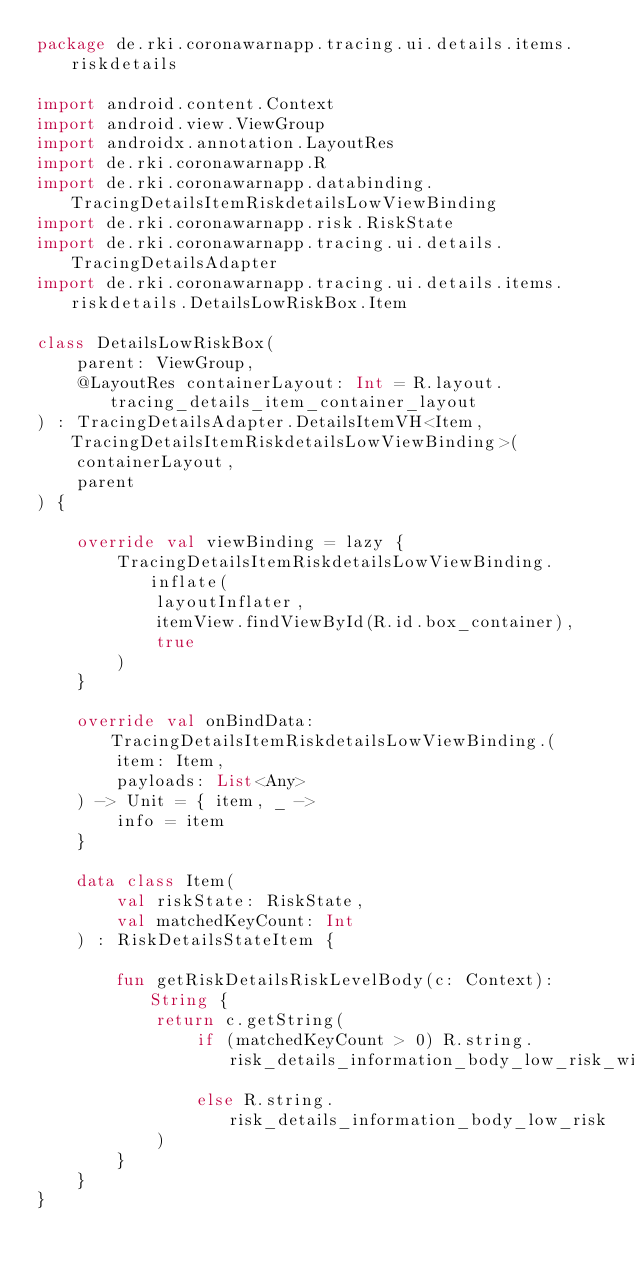<code> <loc_0><loc_0><loc_500><loc_500><_Kotlin_>package de.rki.coronawarnapp.tracing.ui.details.items.riskdetails

import android.content.Context
import android.view.ViewGroup
import androidx.annotation.LayoutRes
import de.rki.coronawarnapp.R
import de.rki.coronawarnapp.databinding.TracingDetailsItemRiskdetailsLowViewBinding
import de.rki.coronawarnapp.risk.RiskState
import de.rki.coronawarnapp.tracing.ui.details.TracingDetailsAdapter
import de.rki.coronawarnapp.tracing.ui.details.items.riskdetails.DetailsLowRiskBox.Item

class DetailsLowRiskBox(
    parent: ViewGroup,
    @LayoutRes containerLayout: Int = R.layout.tracing_details_item_container_layout
) : TracingDetailsAdapter.DetailsItemVH<Item, TracingDetailsItemRiskdetailsLowViewBinding>(
    containerLayout,
    parent
) {

    override val viewBinding = lazy {
        TracingDetailsItemRiskdetailsLowViewBinding.inflate(
            layoutInflater,
            itemView.findViewById(R.id.box_container),
            true
        )
    }

    override val onBindData: TracingDetailsItemRiskdetailsLowViewBinding.(
        item: Item,
        payloads: List<Any>
    ) -> Unit = { item, _ ->
        info = item
    }

    data class Item(
        val riskState: RiskState,
        val matchedKeyCount: Int
    ) : RiskDetailsStateItem {

        fun getRiskDetailsRiskLevelBody(c: Context): String {
            return c.getString(
                if (matchedKeyCount > 0) R.string.risk_details_information_body_low_risk_with_encounter
                else R.string.risk_details_information_body_low_risk
            )
        }
    }
}
</code> 